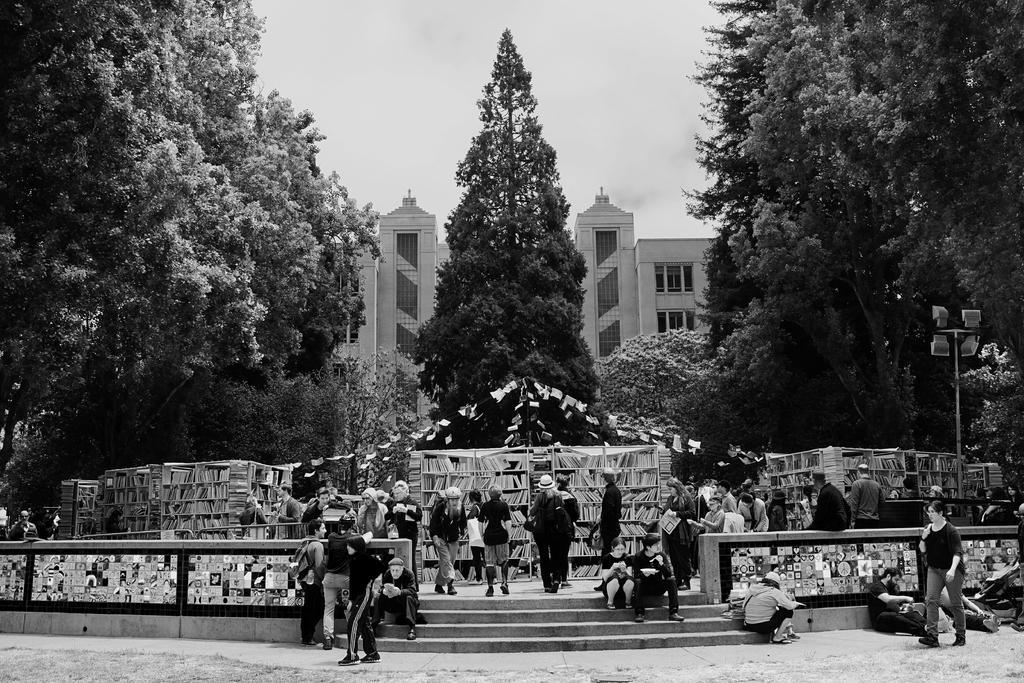How would you summarize this image in a sentence or two? This is an black and white image. At the bottom there are many people on the ground. Few are standing, few are sitting on the stairs and few people are walking. Here I can see many books arranged in the racks. In the background there are trees and a building. At the top of the image I can see the sky. 